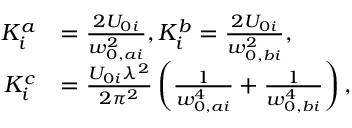Convert formula to latex. <formula><loc_0><loc_0><loc_500><loc_500>\begin{array} { r l } { K _ { i } ^ { a } } & { = \frac { 2 U _ { 0 i } } { w _ { 0 , a i } ^ { 2 } } , K _ { i } ^ { b } = \frac { 2 U _ { 0 i } } { w _ { 0 , b i } ^ { 2 } } , } \\ { K _ { i } ^ { c } } & { = \frac { U _ { 0 i } \lambda ^ { 2 } } { 2 \pi ^ { 2 } } \left ( \frac { 1 } { w _ { 0 , a i } ^ { 4 } } + \frac { 1 } { w _ { 0 , b i } ^ { 4 } } \right ) , } \end{array}</formula> 